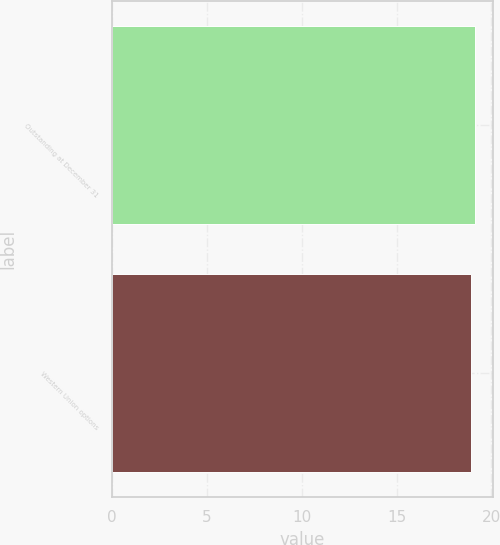Convert chart. <chart><loc_0><loc_0><loc_500><loc_500><bar_chart><fcel>Outstanding at December 31<fcel>Western Union options<nl><fcel>19.11<fcel>18.9<nl></chart> 